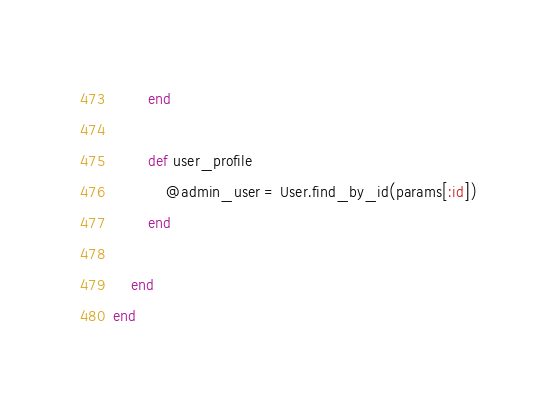Convert code to text. <code><loc_0><loc_0><loc_500><loc_500><_Ruby_>        end

        def user_profile
            @admin_user = User.find_by_id(params[:id])
        end

    end
end
</code> 